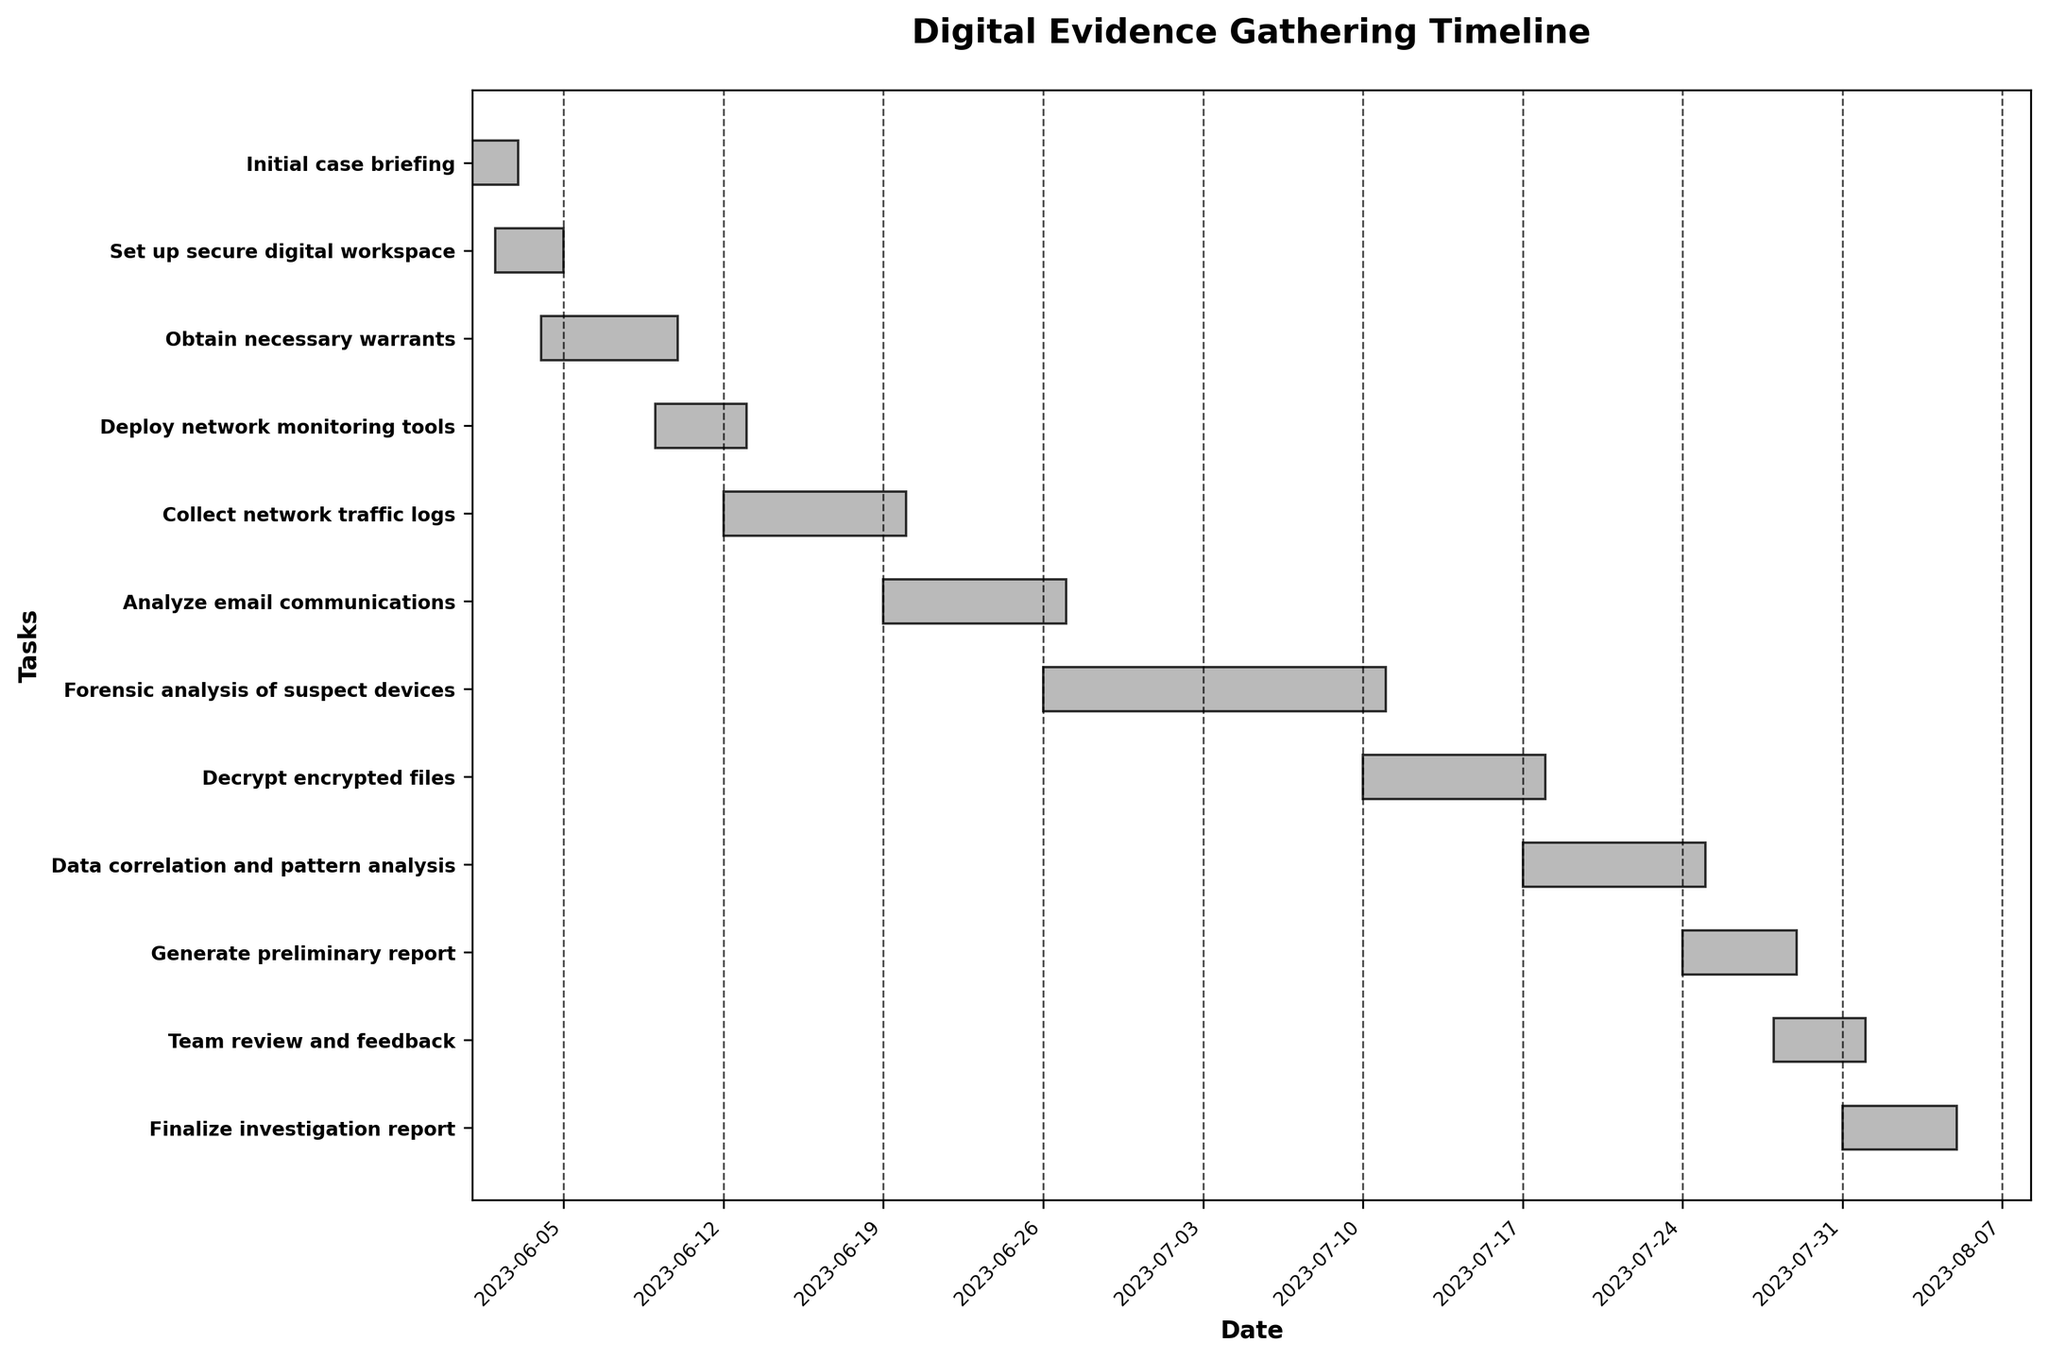What is the title of the chart? The title of the chart is located at the top and it is written in bold. By reading it directly from the chart, we can determine the exact title.
Answer: Digital Evidence Gathering Timeline How long did the 'Obtain necessary warrants' task take? By looking at the 'Obtain necessary warrants' bar and its duration label, we can see the duration from the data provided in days.
Answer: 6 days Which task took the longest time to complete? Observing all the horizontal bars, 'Forensic analysis of suspect devices' has the longest bar, indicating the longest duration.
Answer: Forensic analysis of suspect devices How many tasks took more than one week to complete? By evaluating the duration of each task and counting those with durations greater than 7 days, we find three tasks: 'Collect network traffic logs', 'Forensic analysis of suspect devices', and 'Data correlation and pattern analysis'.
Answer: 3 tasks What is the start and end date of the 'Decrypt encrypted files' task? The start and end dates can be read directly from the 'Decrypt encrypted files' bar on the chart.
Answer: Start: 2023-07-10, End: 2023-07-17 What is the total duration from the start of 'Initial case briefing' to the end of 'Finalize investigation report'? The 'Initial case briefing' starts on 2023-06-01, and 'Finalize investigation report' ends on 2023-08-04. Calculating the total duration: August 4 minus June 1 is 64 days.
Answer: 64 days Which task immediately follows 'Deploy network monitoring tools'? By looking at the sequence of tasks, we see that 'Collect network traffic logs' starts right after 'Deploy network monitoring tools' ends.
Answer: Collect network traffic logs How many tasks start in July? By inspecting the start dates for each task, we count those starting in July, which includes 'Decrypt encrypted files', 'Data correlation and pattern analysis', 'Generate preliminary report', 'Team review and feedback', and 'Finalize investigation report'.
Answer: 5 tasks What is the duration difference between the 'Analyze email communications' and 'Team review and feedback'? The duration for 'Analyze email communications' is 8 days and for 'Team review and feedback' is 4 days. The difference is 8 - 4 = 4 days.
Answer: 4 days 